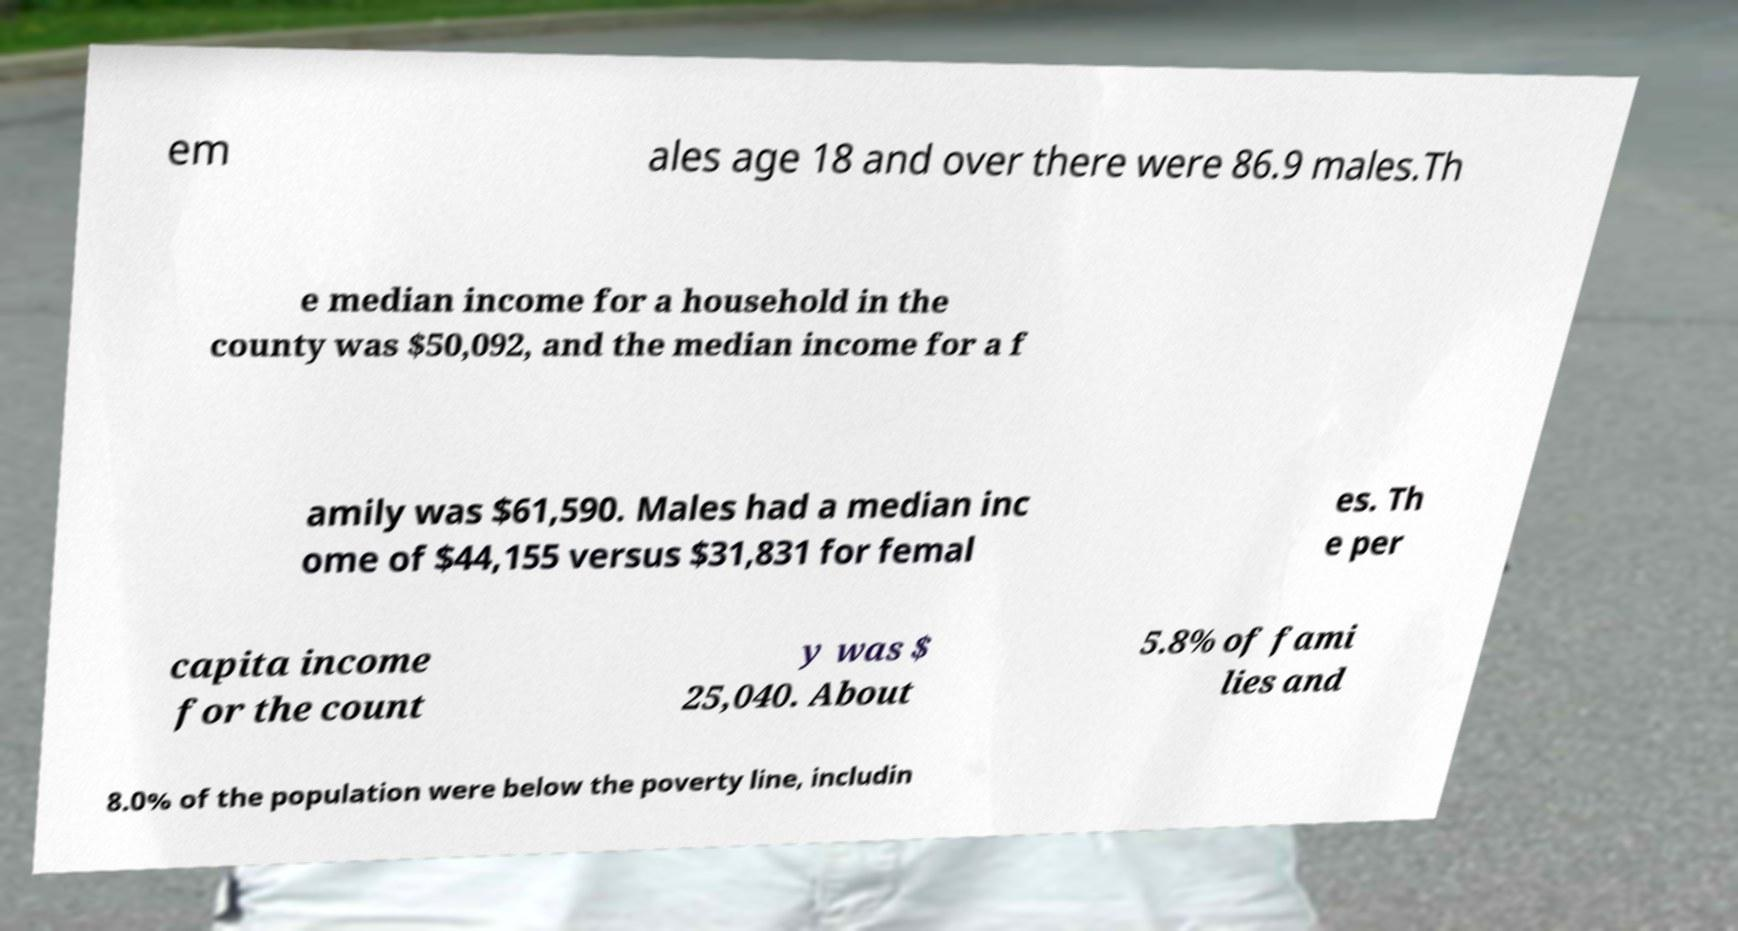What messages or text are displayed in this image? I need them in a readable, typed format. em ales age 18 and over there were 86.9 males.Th e median income for a household in the county was $50,092, and the median income for a f amily was $61,590. Males had a median inc ome of $44,155 versus $31,831 for femal es. Th e per capita income for the count y was $ 25,040. About 5.8% of fami lies and 8.0% of the population were below the poverty line, includin 